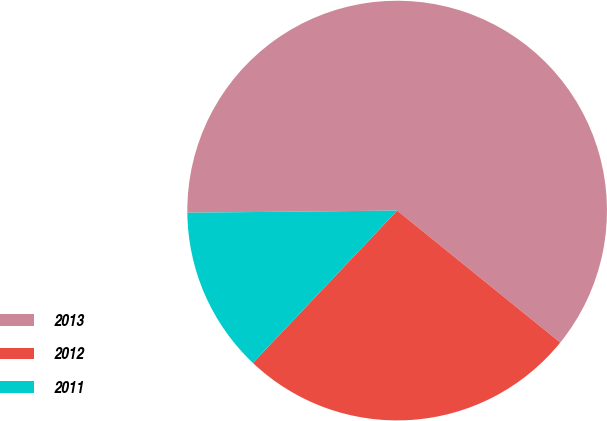Convert chart to OTSL. <chart><loc_0><loc_0><loc_500><loc_500><pie_chart><fcel>2013<fcel>2012<fcel>2011<nl><fcel>60.99%<fcel>26.24%<fcel>12.77%<nl></chart> 